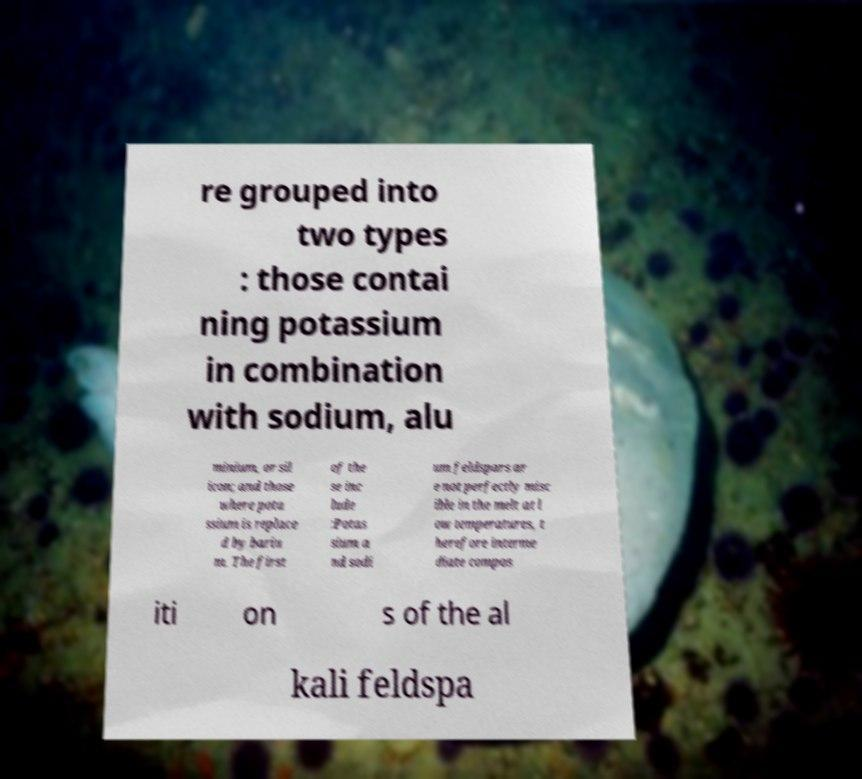Please identify and transcribe the text found in this image. re grouped into two types : those contai ning potassium in combination with sodium, alu minium, or sil icon; and those where pota ssium is replace d by bariu m. The first of the se inc lude :Potas sium a nd sodi um feldspars ar e not perfectly misc ible in the melt at l ow temperatures, t herefore interme diate compos iti on s of the al kali feldspa 